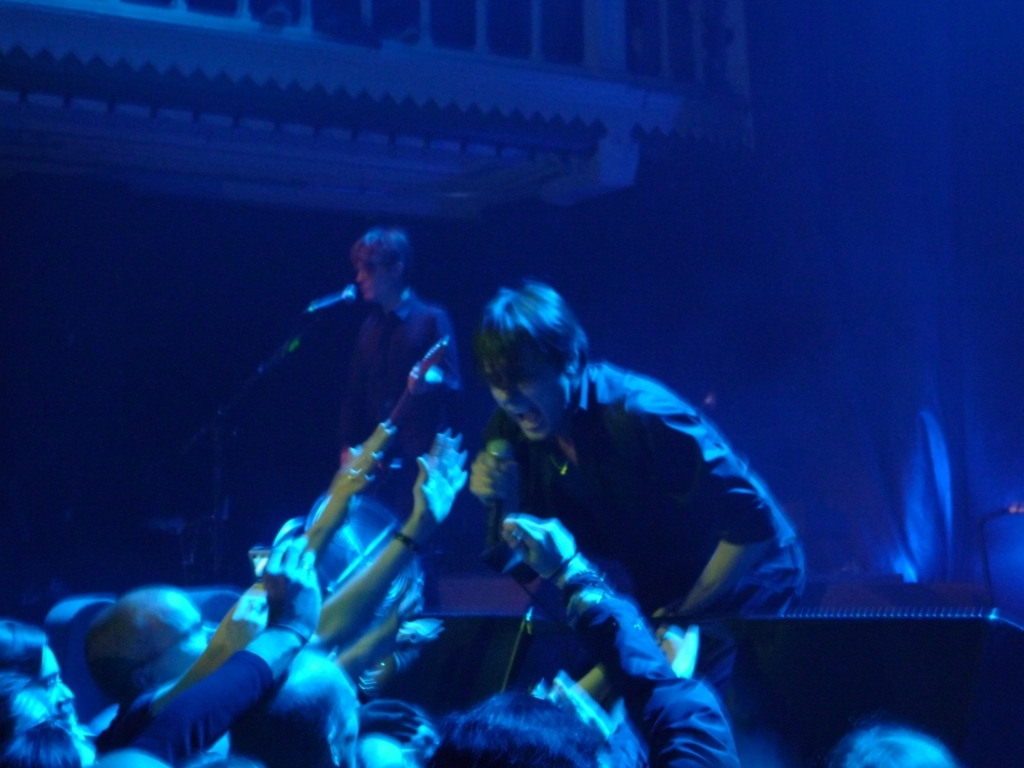What is the focal point of this image? The focal point of the image is the musician in the foreground. His dynamic interaction with the crowd, reaching out as he plays the guitar, captures the viewer's attention and emphasizes the connection between the performer and the audience. How does the lighting affect the perception of the scene? The lighting creates a dramatic effect, with the variations in blues and the spotlighting of the artist emphasizing the energetic performance. It also casts shadows that bring depth to the image and highlight the movement within the scene. 